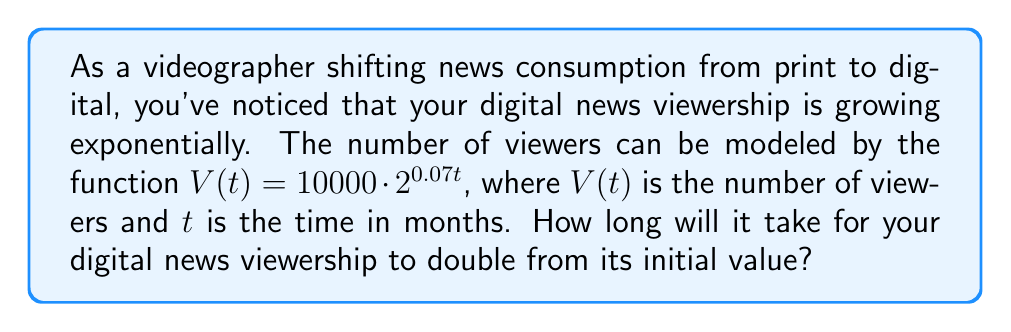Give your solution to this math problem. To solve this problem, we need to use logarithmic equations. Let's approach this step-by-step:

1) We want to find the time $t$ when the viewership doubles. This means:

   $V(t) = 2 \cdot V(0)$

2) Let's substitute the function into this equation:

   $10000 \cdot 2^{0.07t} = 2 \cdot 10000$

3) Simplify:

   $2^{0.07t} = 2$

4) Now, we can apply the logarithm (base 2) to both sides:

   $\log_2(2^{0.07t}) = \log_2(2)$

5) Using the logarithm property $\log_a(a^x) = x$, we get:

   $0.07t \cdot \log_2(2) = 1$

6) Simplify, noting that $\log_2(2) = 1$:

   $0.07t = 1$

7) Solve for $t$:

   $t = \frac{1}{0.07} \approx 14.29$

Therefore, it will take approximately 14.29 months for the viewership to double.
Answer: $t \approx 14.29$ months 